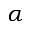Convert formula to latex. <formula><loc_0><loc_0><loc_500><loc_500>\alpha</formula> 